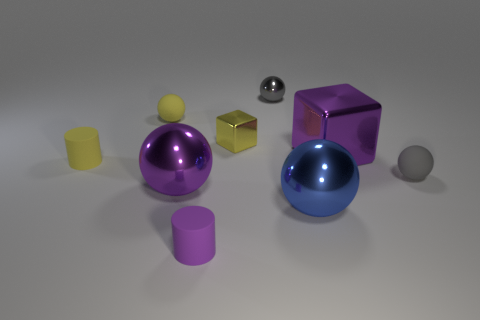The rubber sphere that is to the left of the gray thing that is in front of the yellow rubber sphere is what color?
Ensure brevity in your answer.  Yellow. Do the large cube and the tiny rubber ball in front of the tiny yellow block have the same color?
Offer a very short reply. No. There is a purple cube that is the same material as the small yellow block; what is its size?
Make the answer very short. Large. What is the size of the ball that is the same color as the small cube?
Your answer should be compact. Small. Is the color of the large metallic block the same as the small metal ball?
Your response must be concise. No. Is there a rubber object that is behind the small yellow object that is to the right of the matte object behind the yellow cylinder?
Make the answer very short. Yes. What number of blocks have the same size as the purple shiny ball?
Offer a terse response. 1. Is the size of the yellow matte object that is behind the small yellow cube the same as the matte cylinder that is behind the small purple cylinder?
Keep it short and to the point. Yes. The yellow object that is left of the small yellow cube and in front of the yellow rubber ball has what shape?
Offer a terse response. Cylinder. Are there any other tiny cubes of the same color as the small shiny cube?
Your answer should be compact. No. 